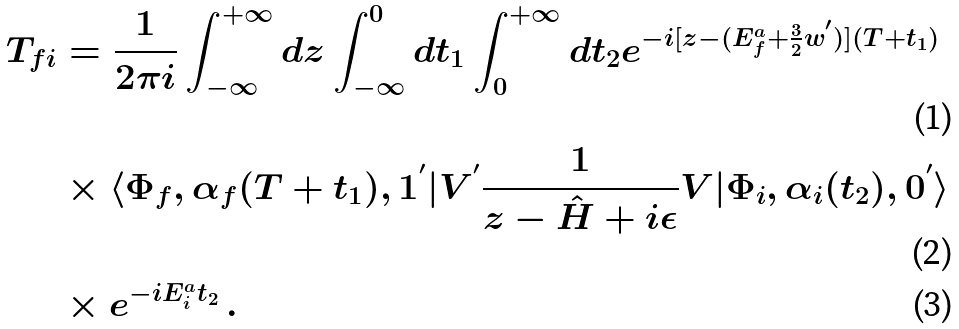Convert formula to latex. <formula><loc_0><loc_0><loc_500><loc_500>T _ { f i } & = \frac { 1 } { 2 \pi i } \int _ { - \infty } ^ { + \infty } d z \int ^ { 0 } _ { - \infty } d t _ { 1 } \int ^ { + \infty } _ { 0 } d t _ { 2 } e ^ { - i [ z - ( E ^ { a } _ { f } + \frac { 3 } { 2 } w ^ { ^ { \prime } } ) ] ( T + t _ { 1 } ) } \\ & \times \langle \Phi _ { f } , \alpha _ { f } ( T + t _ { 1 } ) , 1 ^ { ^ { \prime } } | V ^ { ^ { \prime } } \frac { 1 } { z - \hat { H } + i \epsilon } V | \Phi _ { i } , \alpha _ { i } ( t _ { 2 } ) , 0 ^ { ^ { \prime } } \rangle \\ & \times e ^ { - i E ^ { a } _ { i } t _ { 2 } } \, .</formula> 